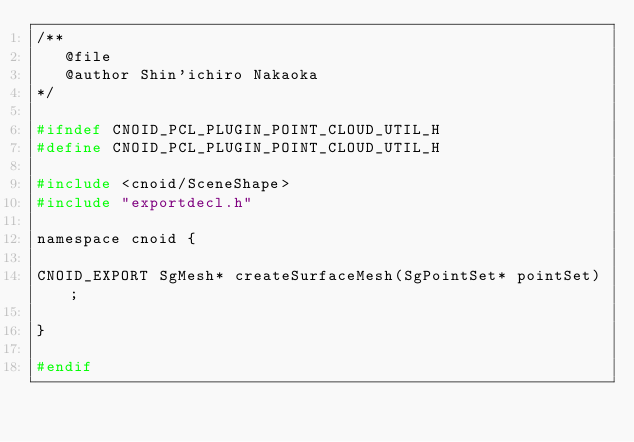<code> <loc_0><loc_0><loc_500><loc_500><_C_>/**
   @file
   @author Shin'ichiro Nakaoka
*/

#ifndef CNOID_PCL_PLUGIN_POINT_CLOUD_UTIL_H
#define CNOID_PCL_PLUGIN_POINT_CLOUD_UTIL_H

#include <cnoid/SceneShape>
#include "exportdecl.h"

namespace cnoid {

CNOID_EXPORT SgMesh* createSurfaceMesh(SgPointSet* pointSet);

}

#endif
</code> 